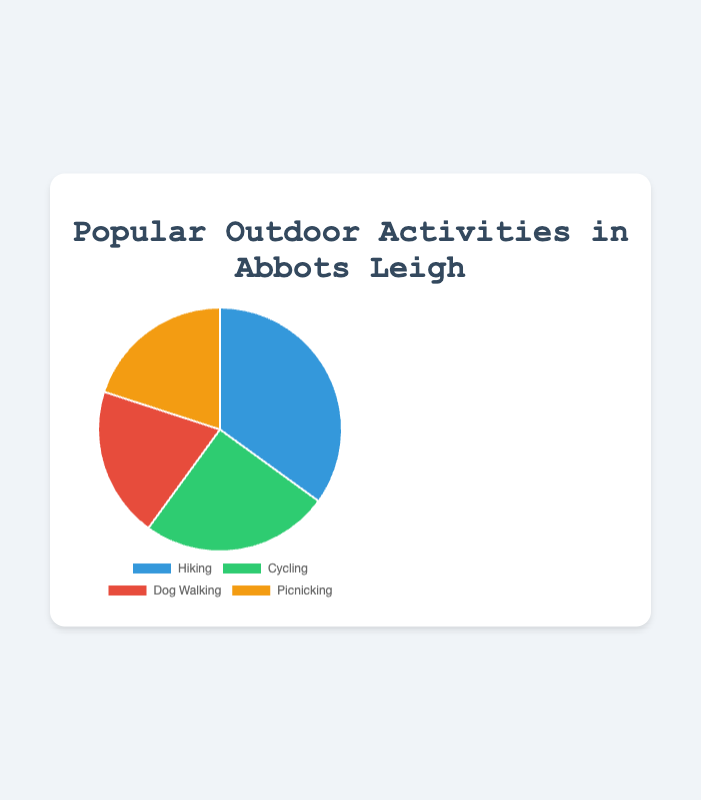Which activity is the most popular? Hiking has the highest percentage at 35%, which can be easily seen as the largest section of the pie chart.
Answer: Hiking Which two activities have the same popularity percentage? Both Dog Walking and Picnicking have a popularity percentage of 20%, as shown by the two equal-sized sections of the pie chart.
Answer: Dog Walking and Picnicking What is the combined popularity percentage of Dog Walking and Picnicking? The popularity percentages of Dog Walking and Picnicking are both 20%. Adding these together gives 20% + 20% = 40%.
Answer: 40% Which activity is less popular than Cycling but more popular than Picnicking? Cyclying has a popularity percentage of 25%, which is more than Dog Walking and Picnicking (both 20%). Since Dog Walking and Picnicking are tied, neither of them meets the criteria, and only Dog Walking fits being between 25% and 20%.
Answer: Dog Walking How much more popular is Hiking compared to Cycling? Hiking has a popularity percentage of 35%, while Cycling has 25%. The difference can be calculated as 35% - 25% = 10%.
Answer: 10% Which activity has the smallest section in the pie chart? Both Dog Walking and Picnicking have the smallest sections, each with a 20% popularity percentage.
Answer: Dog Walking and Picnicking By how much do the sections of Hiking and Cycling together exceed the sections of Dog Walking and Picnicking combined? The percentages for Hiking and Cycling are 35% and 25% respectively, summing up to 60%. Dog Walking and Picnicking each have 20%, combining to 40%. The difference is 60% - 40% = 20%.
Answer: 20% How many more percentage points is the popularity of Hiking than Dog Walking? Hiking is 35% popular, and Dog Walking is 20% popular. The difference is 35% - 20% = 15%.
Answer: 15% 